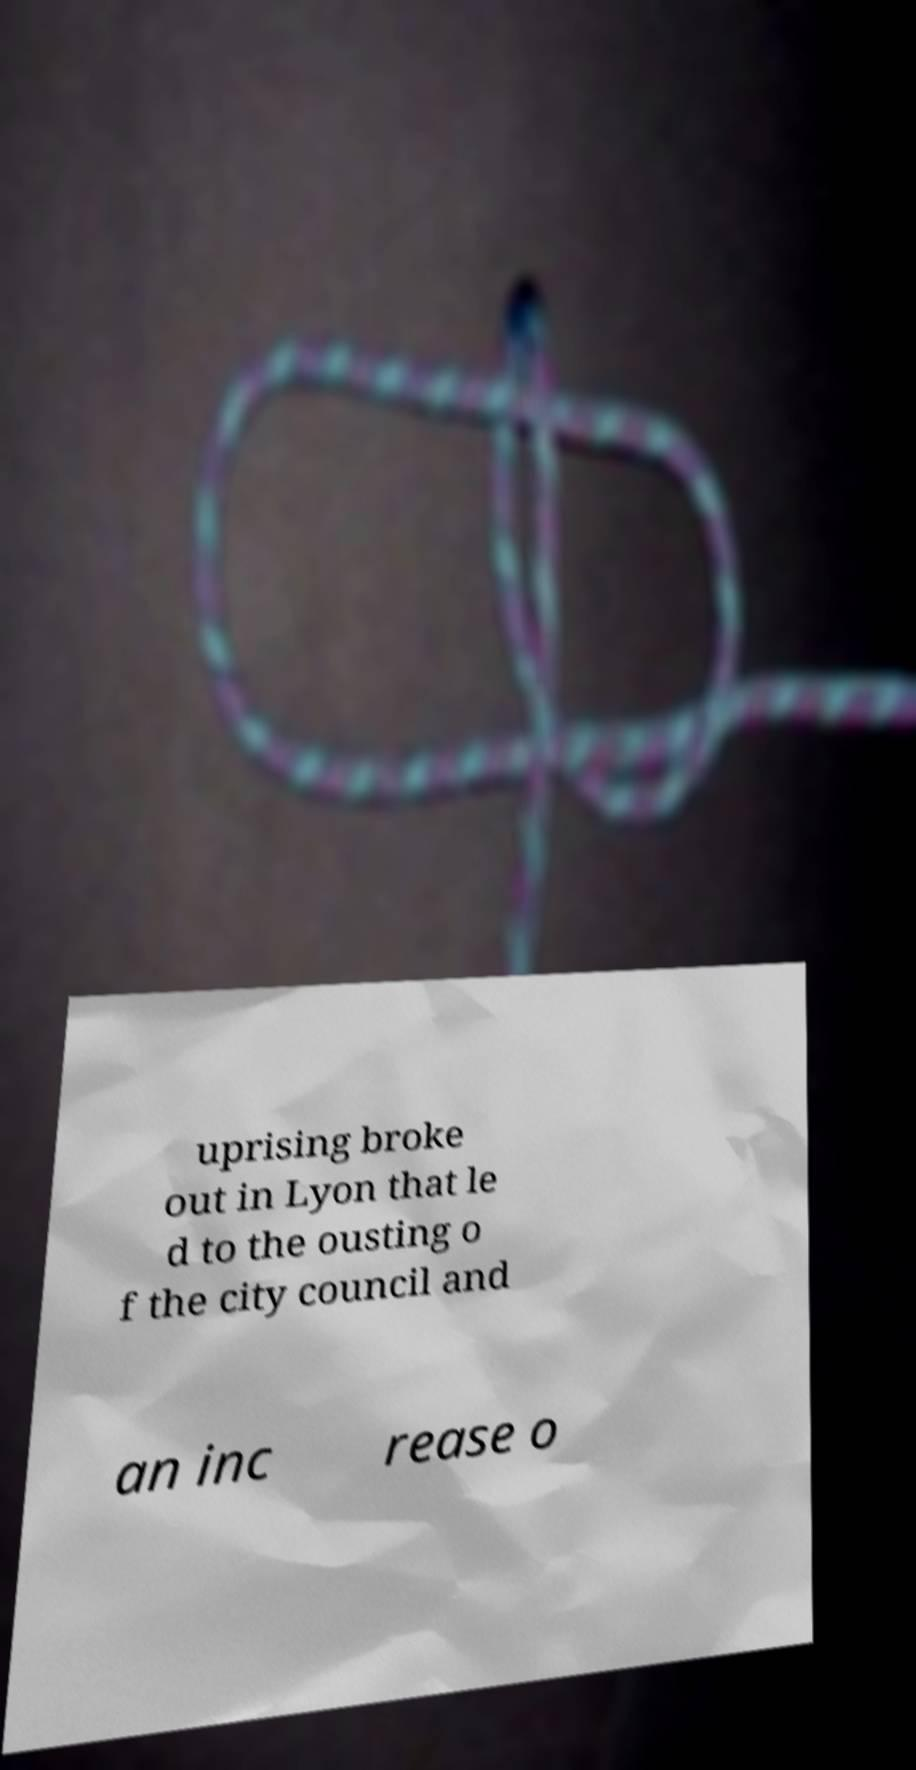Can you accurately transcribe the text from the provided image for me? uprising broke out in Lyon that le d to the ousting o f the city council and an inc rease o 